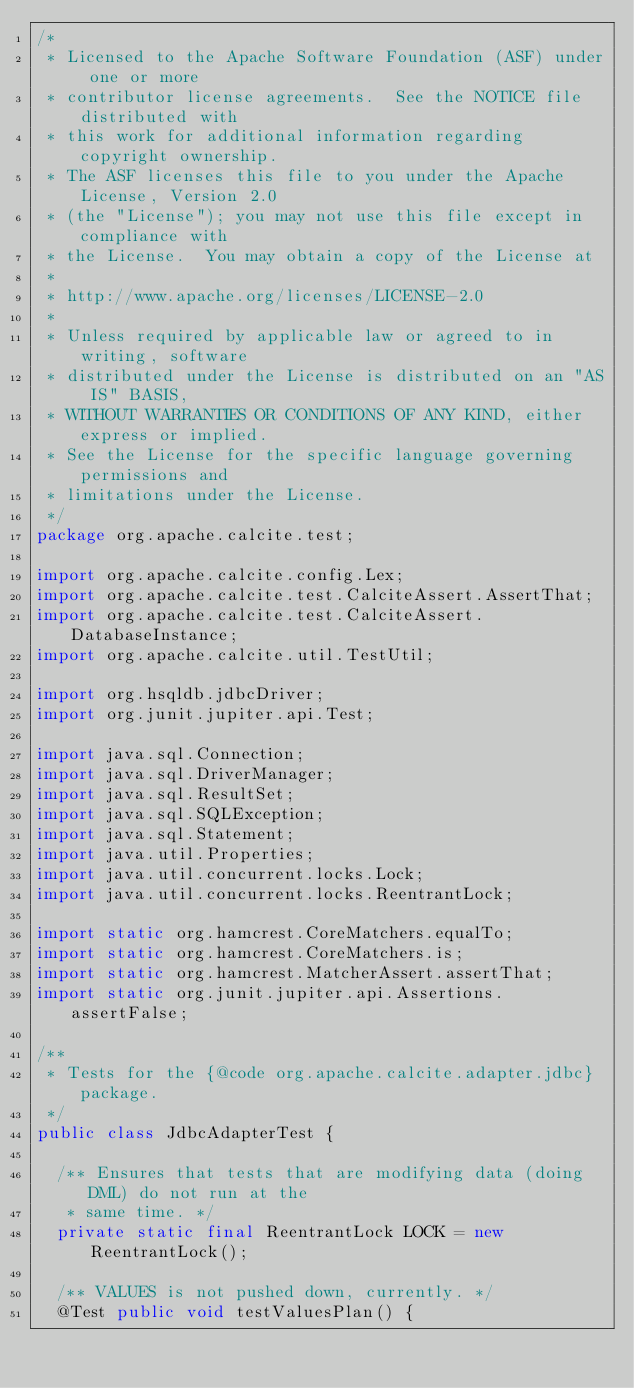Convert code to text. <code><loc_0><loc_0><loc_500><loc_500><_Java_>/*
 * Licensed to the Apache Software Foundation (ASF) under one or more
 * contributor license agreements.  See the NOTICE file distributed with
 * this work for additional information regarding copyright ownership.
 * The ASF licenses this file to you under the Apache License, Version 2.0
 * (the "License"); you may not use this file except in compliance with
 * the License.  You may obtain a copy of the License at
 *
 * http://www.apache.org/licenses/LICENSE-2.0
 *
 * Unless required by applicable law or agreed to in writing, software
 * distributed under the License is distributed on an "AS IS" BASIS,
 * WITHOUT WARRANTIES OR CONDITIONS OF ANY KIND, either express or implied.
 * See the License for the specific language governing permissions and
 * limitations under the License.
 */
package org.apache.calcite.test;

import org.apache.calcite.config.Lex;
import org.apache.calcite.test.CalciteAssert.AssertThat;
import org.apache.calcite.test.CalciteAssert.DatabaseInstance;
import org.apache.calcite.util.TestUtil;

import org.hsqldb.jdbcDriver;
import org.junit.jupiter.api.Test;

import java.sql.Connection;
import java.sql.DriverManager;
import java.sql.ResultSet;
import java.sql.SQLException;
import java.sql.Statement;
import java.util.Properties;
import java.util.concurrent.locks.Lock;
import java.util.concurrent.locks.ReentrantLock;

import static org.hamcrest.CoreMatchers.equalTo;
import static org.hamcrest.CoreMatchers.is;
import static org.hamcrest.MatcherAssert.assertThat;
import static org.junit.jupiter.api.Assertions.assertFalse;

/**
 * Tests for the {@code org.apache.calcite.adapter.jdbc} package.
 */
public class JdbcAdapterTest {

  /** Ensures that tests that are modifying data (doing DML) do not run at the
   * same time. */
  private static final ReentrantLock LOCK = new ReentrantLock();

  /** VALUES is not pushed down, currently. */
  @Test public void testValuesPlan() {</code> 